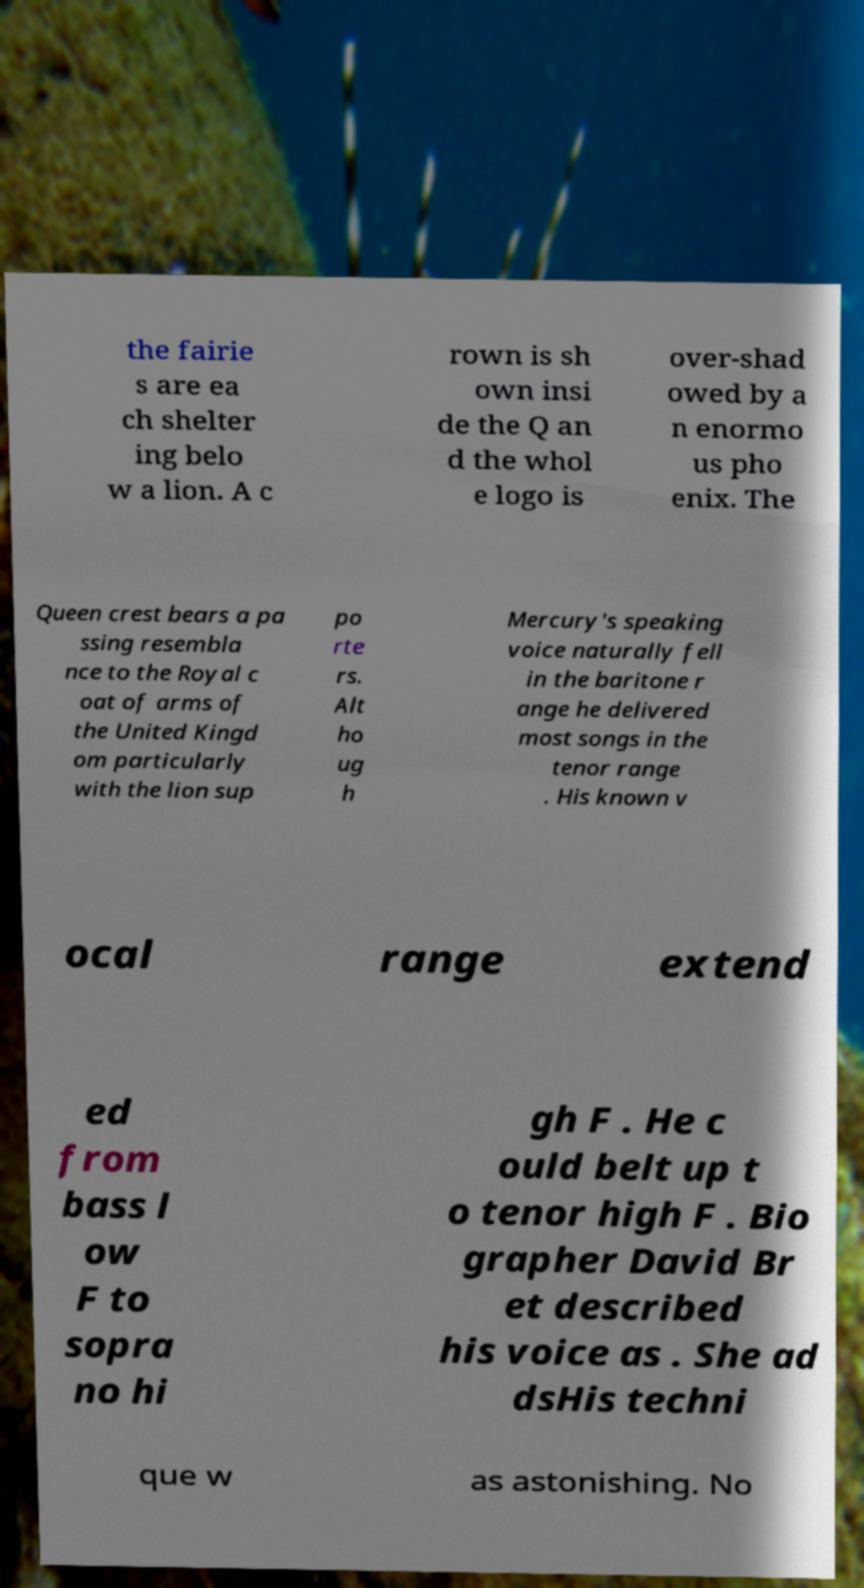Can you accurately transcribe the text from the provided image for me? the fairie s are ea ch shelter ing belo w a lion. A c rown is sh own insi de the Q an d the whol e logo is over-shad owed by a n enormo us pho enix. The Queen crest bears a pa ssing resembla nce to the Royal c oat of arms of the United Kingd om particularly with the lion sup po rte rs. Alt ho ug h Mercury's speaking voice naturally fell in the baritone r ange he delivered most songs in the tenor range . His known v ocal range extend ed from bass l ow F to sopra no hi gh F . He c ould belt up t o tenor high F . Bio grapher David Br et described his voice as . She ad dsHis techni que w as astonishing. No 